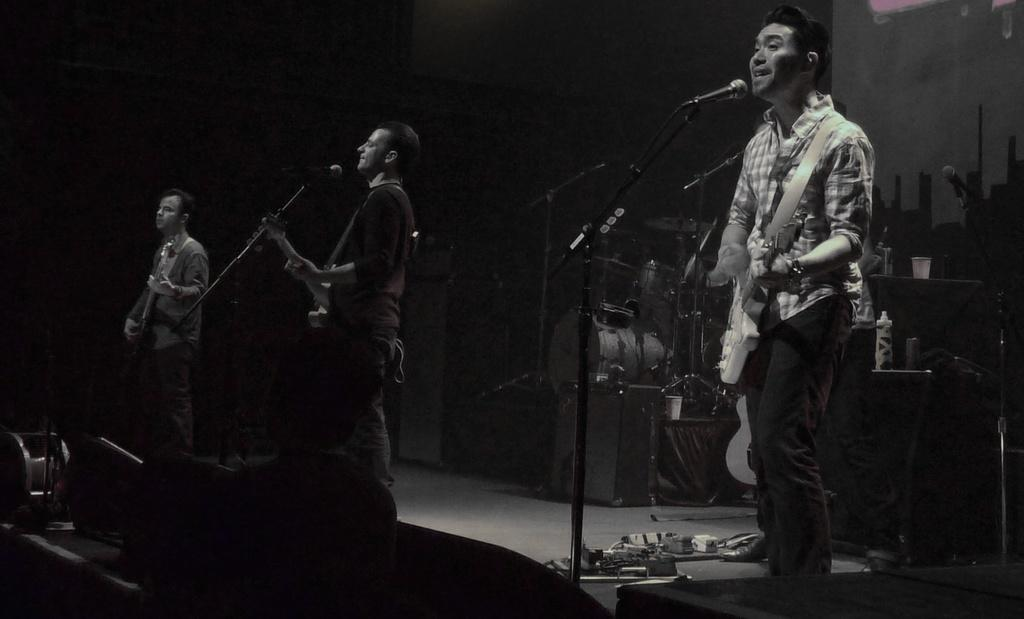How many people are on the stage in the image? There are three persons on the stage. What are the persons holding in the image? Each person is holding a guitar. What are the persons doing with the guitars? The persons are playing the guitars. What can be seen on the stage besides the persons and guitars? There is a microphone on the stage. What else related to music can be seen in the image? Musical instruments are visible in the background. What type of sack is being used to hold the guitars on stage? There is no sack present in the image; the persons are holding the guitars directly. 